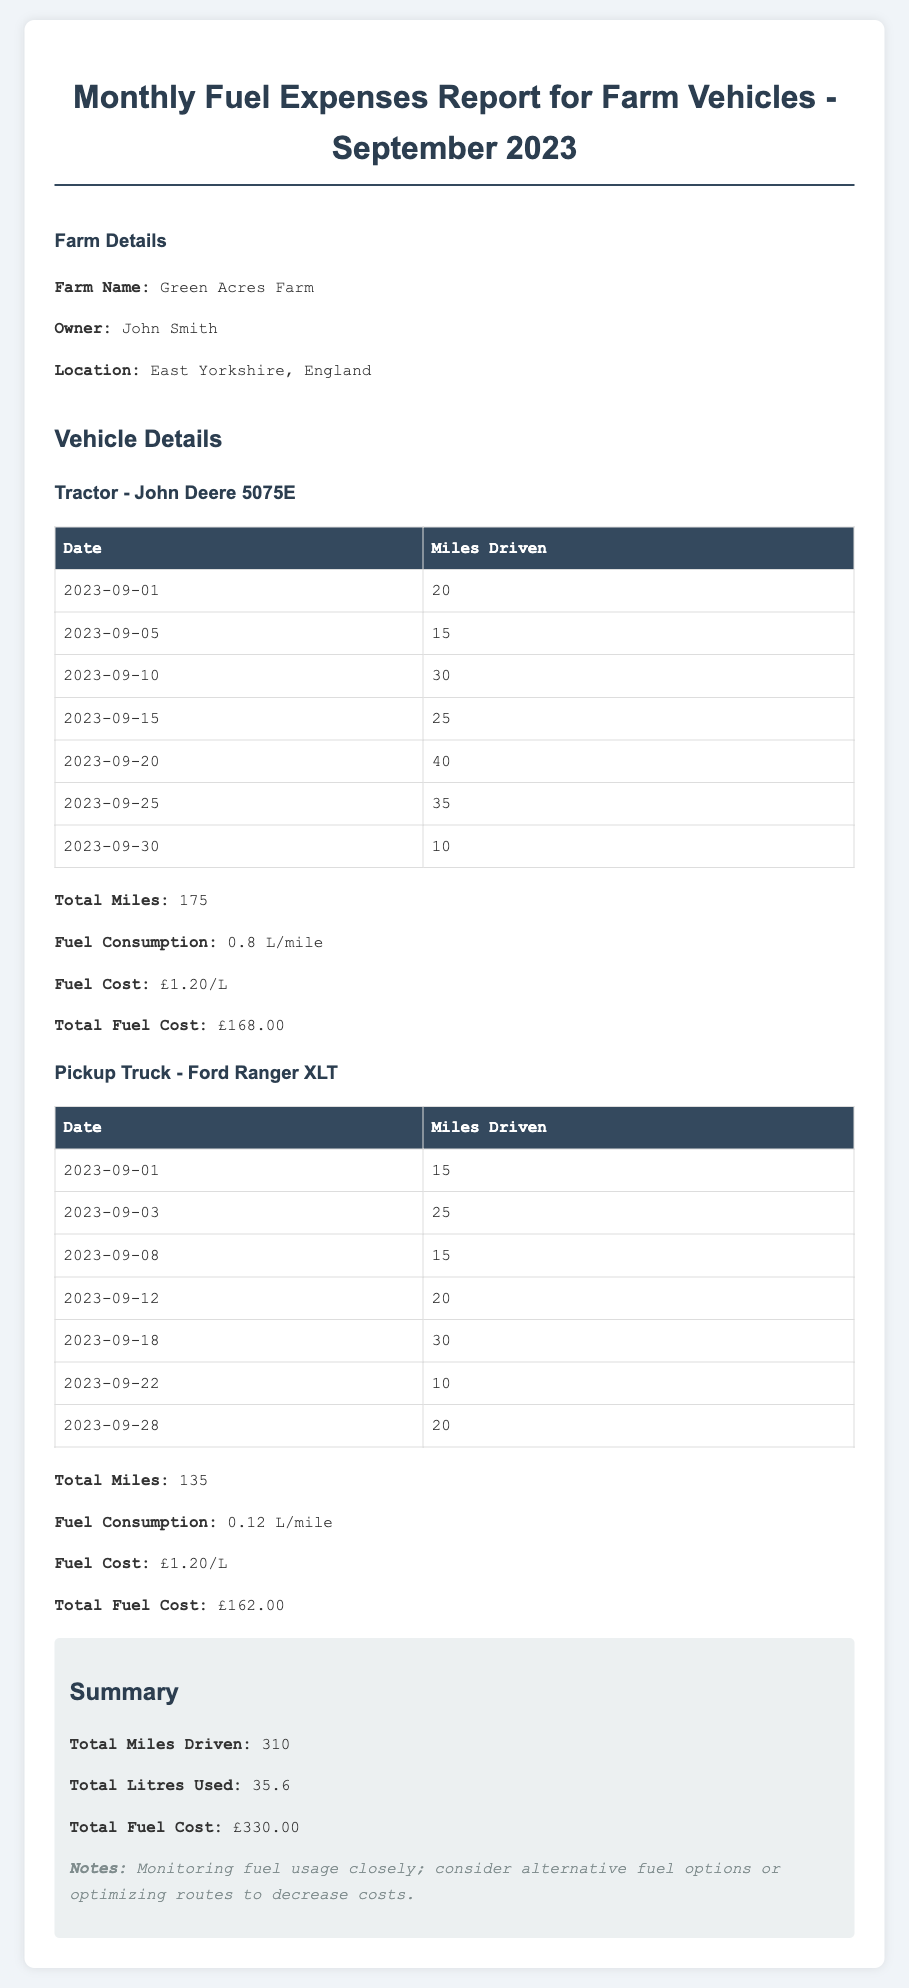What is the farm name? The farm name is mentioned in the farm details section of the document.
Answer: Green Acres Farm Who is the owner of the farm? The owner of the farm is listed in the farm details section.
Answer: John Smith What is the total mileage for the tractor? The total mileage is calculated based on the mileage log presented for the tractor.
Answer: 175 What is the fuel consumption for the pickup truck? The fuel consumption is listed under the vehicle details for the pickup truck.
Answer: 0.12 L/mile What is the total fuel cost for all vehicles combined? The total fuel cost is found in the summary section of the report, summing both vehicles' costs.
Answer: £330.00 How many miles were driven in total for the month? The total miles driven is the sum of the mileage logs for both vehicles as noted in the summary section.
Answer: 310 What is the fuel cost per liter? The fuel cost per liter is specified in the vehicle details for both vehicles.
Answer: £1.20/L What date did the tractor have the highest mileage recorded? The mileage log for the tractor includes dates, which can be cross-checked to determine the day with the highest.
Answer: 2023-09-20 What should be monitored closely according to the notes? The notes in the summary section suggest something to keep an eye on for operational efficiency.
Answer: Fuel usage 